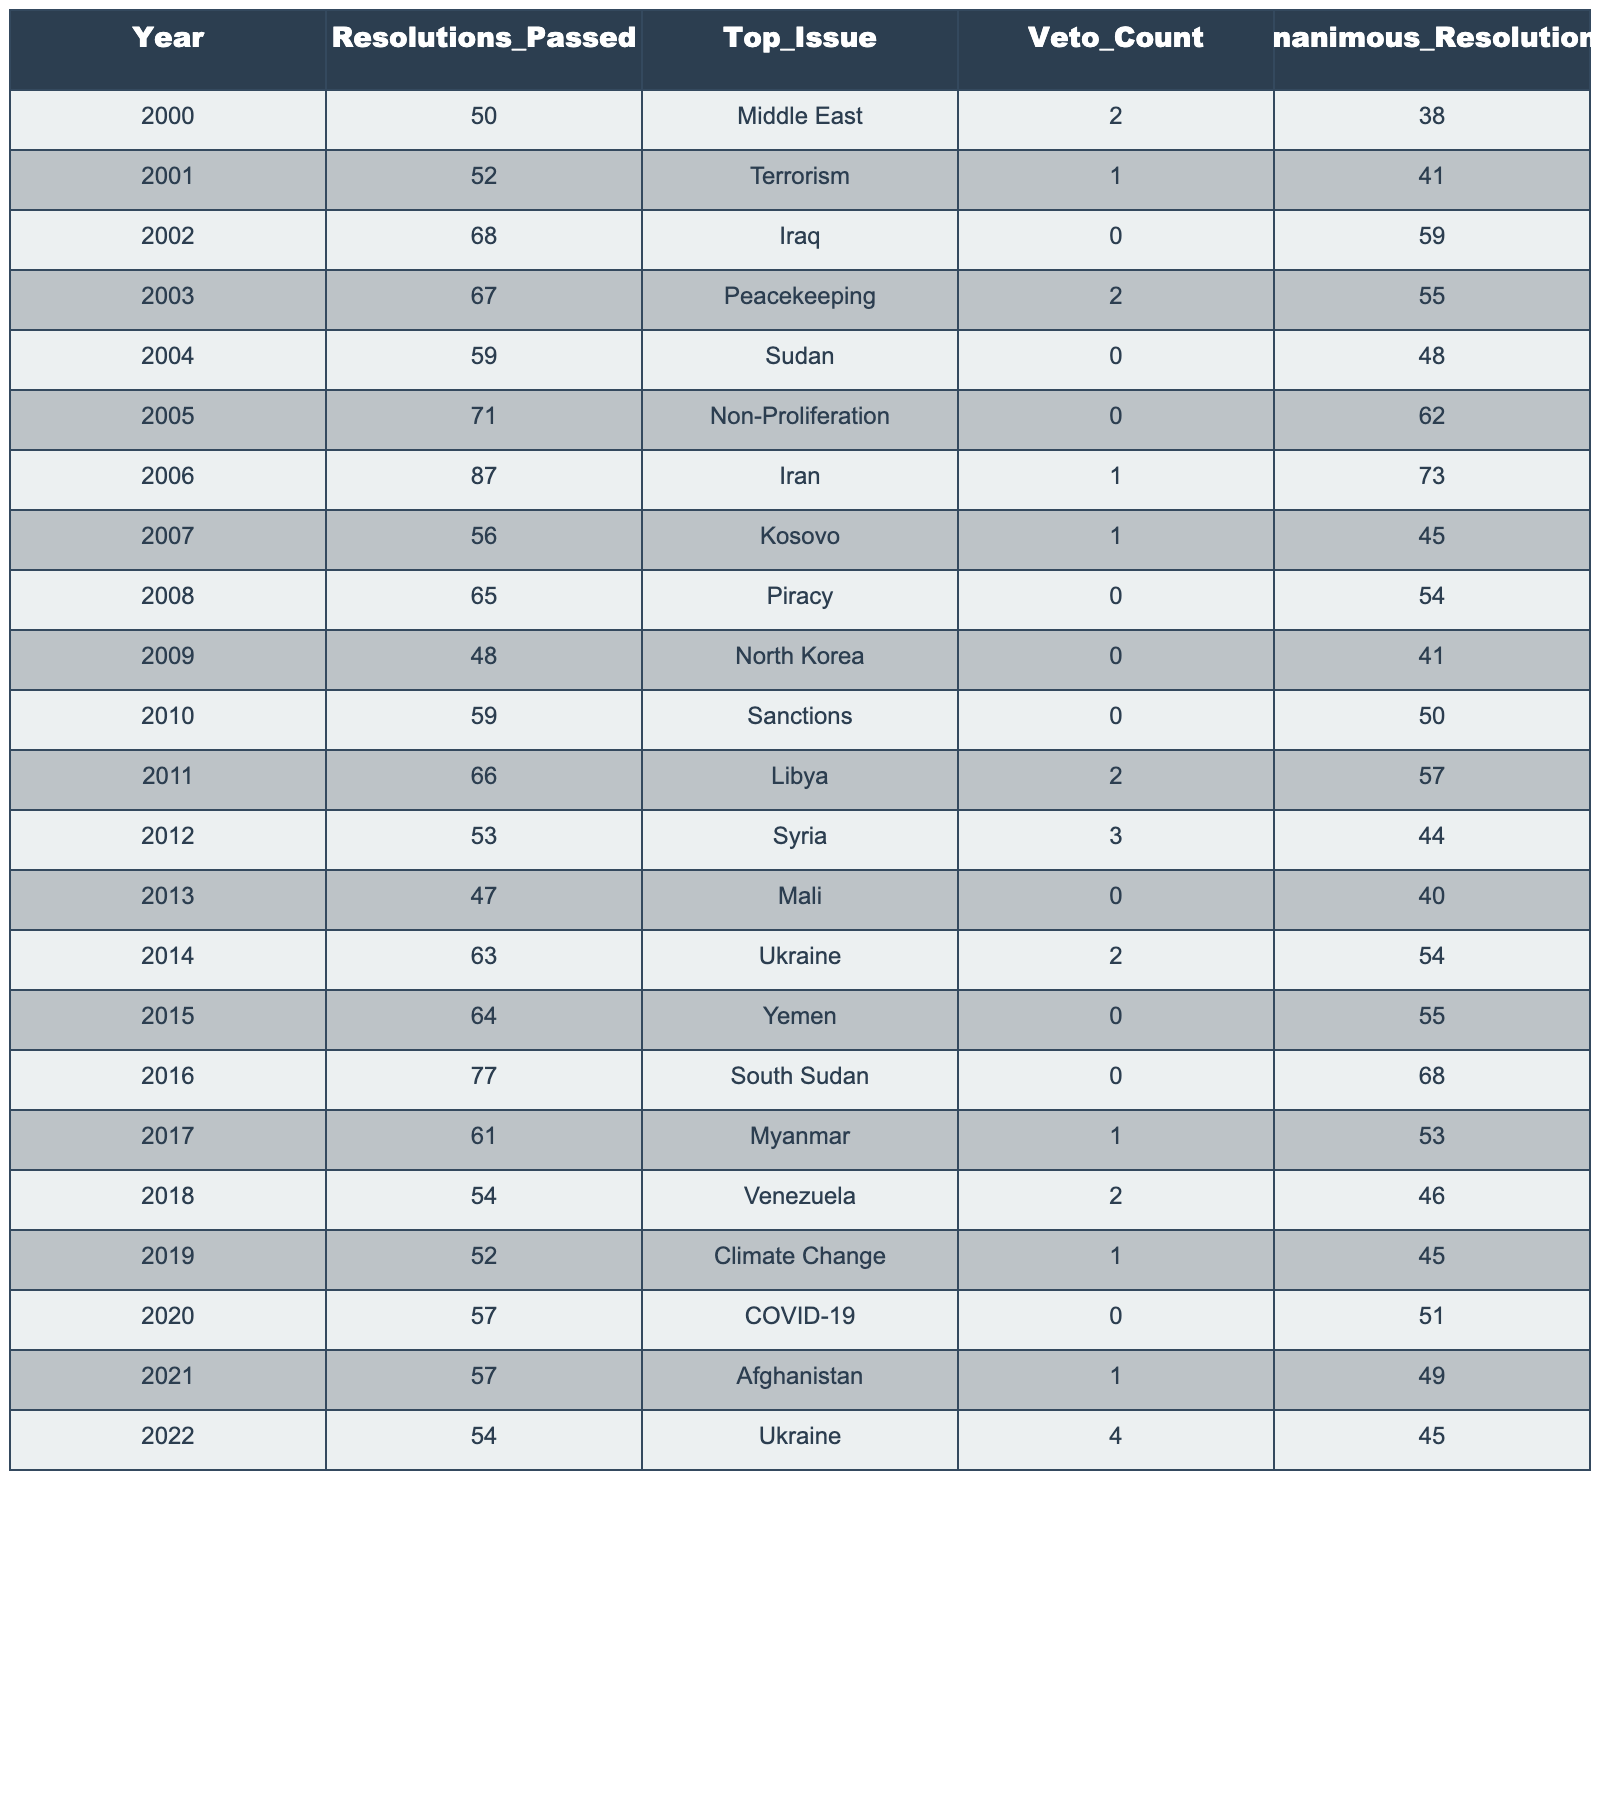What was the top issue in 2006? The table states that the top issue in 2006 was Iran. This information is directly visible under the "Top_Issue" column for the year 2006.
Answer: Iran How many resolutions were passed in 2015? According to the table, there were 64 resolutions passed in the year 2015, found in the "Resolutions_Passed" column for that year.
Answer: 64 What is the veto count for the year with the highest number of resolutions passed? The year with the highest number of resolutions passed is 2006 with 87 resolutions, and its veto count is 1. This is determined by scanning the "Resolutions_Passed" column for the maximum value and checking the corresponding veto count.
Answer: 1 How many resolutions were passed in years where the top issue was related to the Middle East? The years with Middle East-related issues are 2000 and 2006. Adding the resolutions gives us 50 (in 2000) + 87 (in 2006) = 137. This requires looking for years with "Middle East" in the "Top_Issue" column and summing the resolutions from the "Resolutions_Passed" column for those years.
Answer: 137 Was there any year from 2000 to 2022 with more than 70 resolutions that had a veto count of 0? Yes, in 2005 there were 71 resolutions passed with a veto count of 0. We find all years with resolutions greater than 70 and check the veto count to confirm.
Answer: Yes What is the average number of resolutions passed per year from 2000 to 2022? To find the average, we sum all resolutions passed from the table: 50+52+68+67+59+71+87+56+65+48+59+66+53+47+63+64+77+61+54+52+57+57+54 = 1360. There are 23 data points (years), leading to an average of 1360/23 ≈ 59.13. This computation involves both summing the resolutions and dividing by the total number of years.
Answer: 59.13 In which year was the highest number of unanimous resolutions passed, and how many were there? The highest number of unanimous resolutions was 73 in the year 2006. This can be found by reviewing the "Unanimous_Resolutions" column to identify the maximum value and its corresponding year.
Answer: 2006, 73 During which years were there more resolutions passed than the average number of resolutions for the entire period from 2000 to 2022? The average is 59.13. The years with more than this number of resolutions are 2002 (68), 2003 (67), 2005 (71), 2006 (87), 2011 (66), 2014 (63), and 2015 (64). This involves comparing each year's resolutions against the calculated average.
Answer: 2002, 2003, 2005, 2006, 2011, 2014, 2015 Which issue had the highest veto count in a single year, and what was the count? The issue with the highest veto count was Ukraine in 2022, with a count of 4. We identify the maximum value in the "Veto_Count" column and check the corresponding "Top_Issue."
Answer: Ukraine, 4 